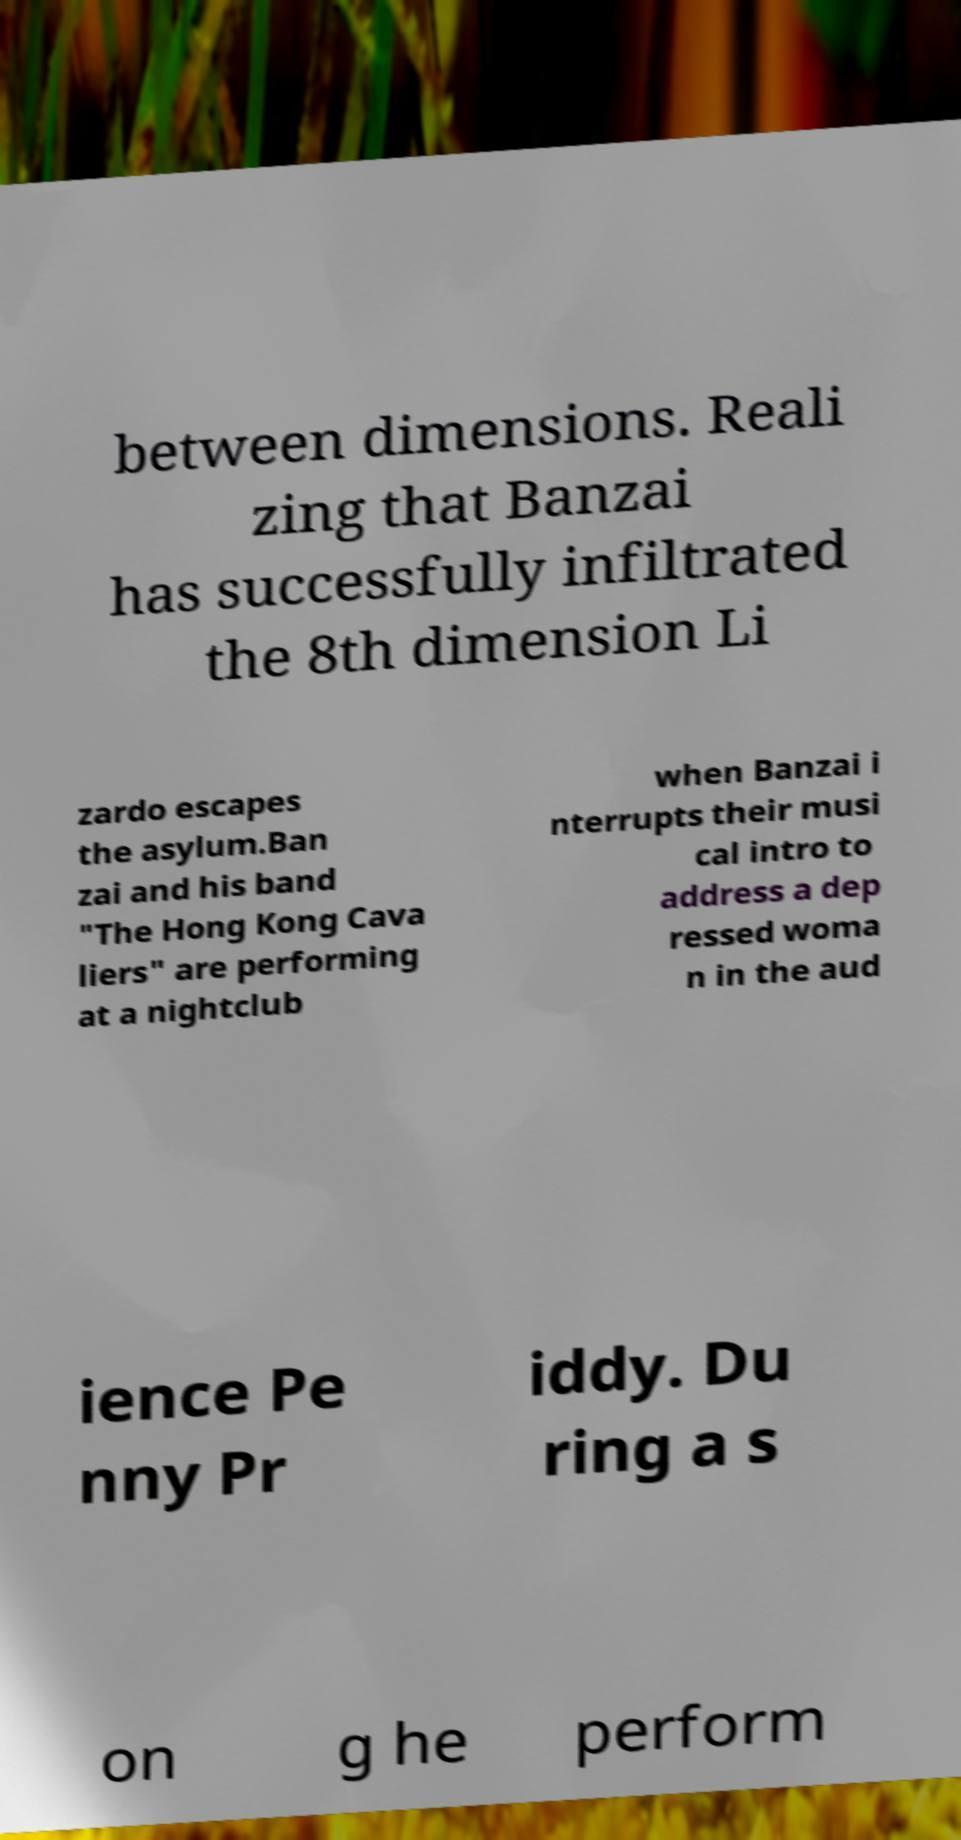What messages or text are displayed in this image? I need them in a readable, typed format. between dimensions. Reali zing that Banzai has successfully infiltrated the 8th dimension Li zardo escapes the asylum.Ban zai and his band "The Hong Kong Cava liers" are performing at a nightclub when Banzai i nterrupts their musi cal intro to address a dep ressed woma n in the aud ience Pe nny Pr iddy. Du ring a s on g he perform 